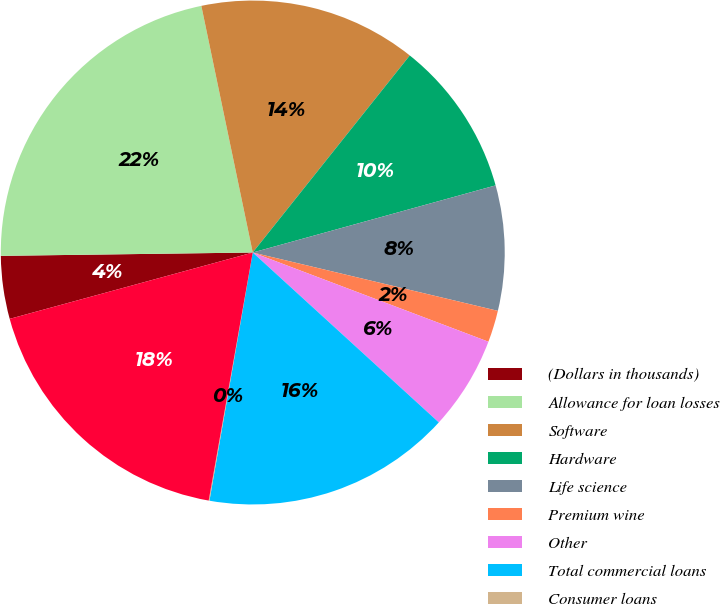<chart> <loc_0><loc_0><loc_500><loc_500><pie_chart><fcel>(Dollars in thousands)<fcel>Allowance for loan losses<fcel>Software<fcel>Hardware<fcel>Life science<fcel>Premium wine<fcel>Other<fcel>Total commercial loans<fcel>Consumer loans<fcel>Total charge-offs<nl><fcel>4.03%<fcel>21.94%<fcel>13.98%<fcel>10.0%<fcel>8.01%<fcel>2.04%<fcel>6.02%<fcel>15.97%<fcel>0.05%<fcel>17.96%<nl></chart> 